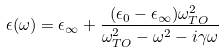<formula> <loc_0><loc_0><loc_500><loc_500>\epsilon ( \omega ) = \epsilon _ { \infty } + \frac { ( \epsilon _ { 0 } - \epsilon _ { \infty } ) \omega _ { T O } ^ { 2 } } { \omega _ { T O } ^ { 2 } - \omega ^ { 2 } - i \gamma \omega }</formula> 